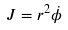<formula> <loc_0><loc_0><loc_500><loc_500>J = r ^ { 2 } \dot { \phi }</formula> 